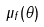Convert formula to latex. <formula><loc_0><loc_0><loc_500><loc_500>\mu _ { f } ( \theta )</formula> 